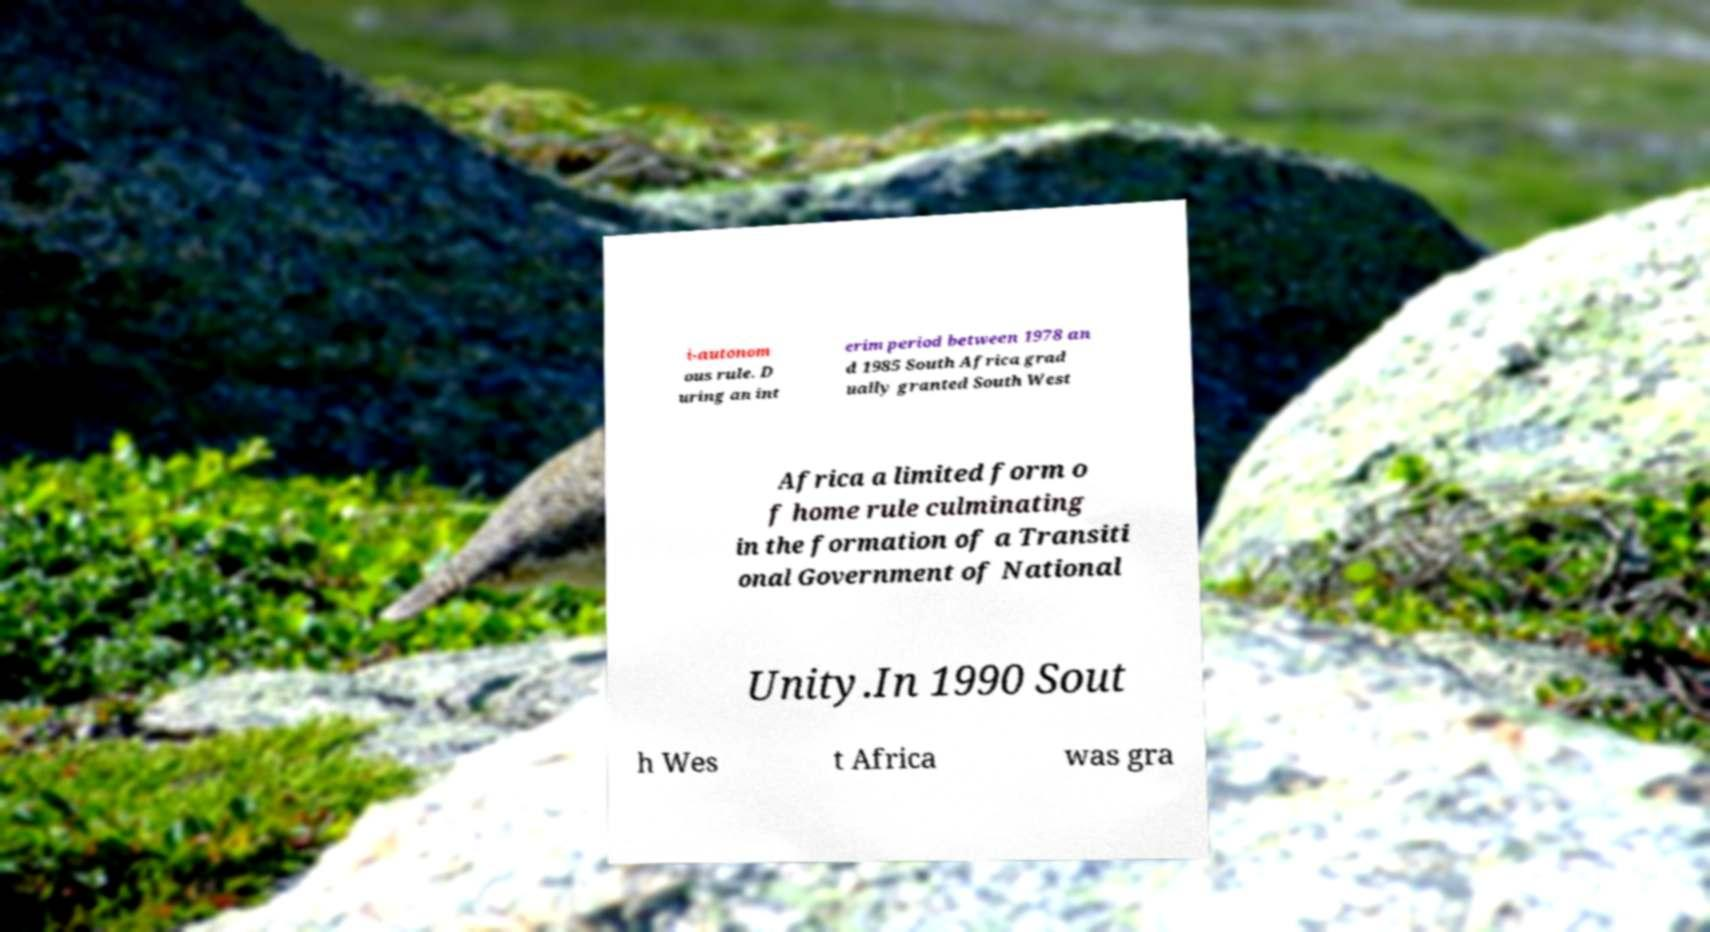Could you extract and type out the text from this image? i-autonom ous rule. D uring an int erim period between 1978 an d 1985 South Africa grad ually granted South West Africa a limited form o f home rule culminating in the formation of a Transiti onal Government of National Unity.In 1990 Sout h Wes t Africa was gra 